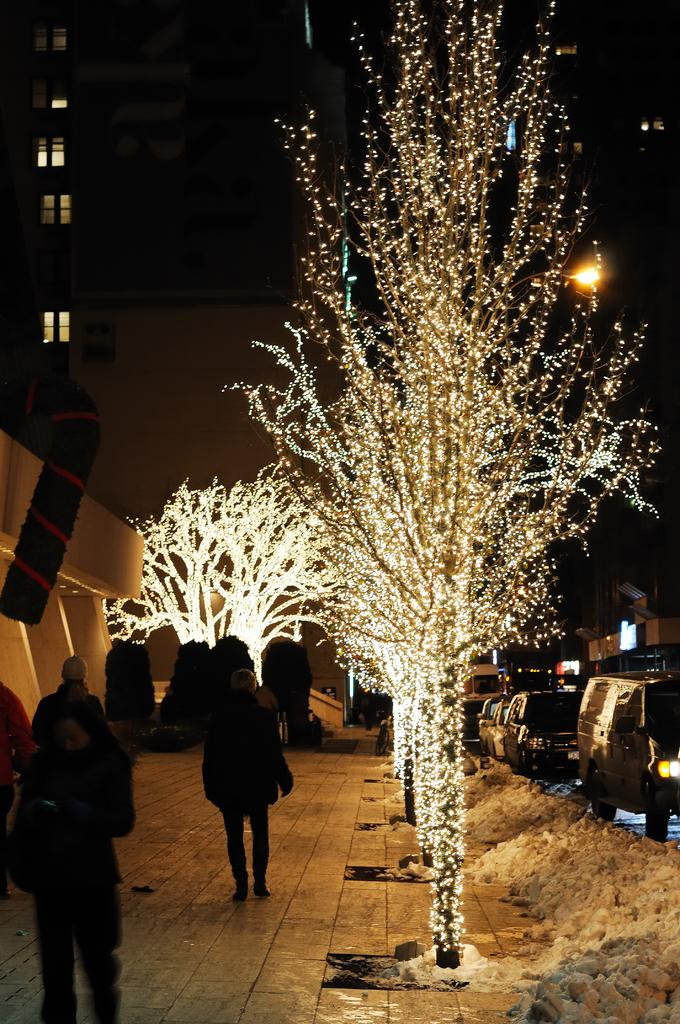What type of structures can be seen in the image? There are buildings in the image. What are the people in the image doing? There are people walking in the image. What is unique about the trees in the image? The trees in the image are lighted. What is moving along the road in the image? There are vehicles on the road in the image. What type of yam is being used to create the art in the image? There is no yam or art present in the image; it features buildings, people walking, lighted trees, and vehicles on the road. 